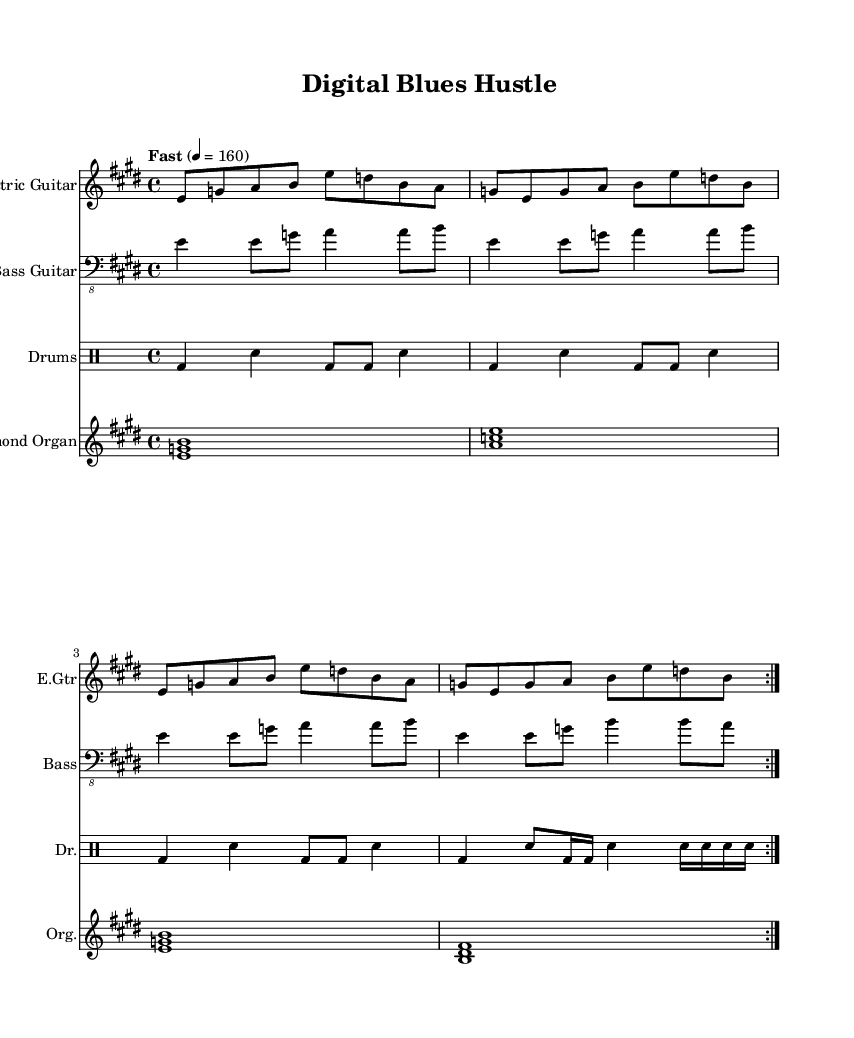What is the key signature of this music? The key signature is E major, which has four sharps: F#, C#, G#, and D#. This can be determined by looking at the key indicated at the beginning of the score.
Answer: E major What is the time signature of this music? The time signature is 4/4, which is indicated at the beginning of the score. This means there are four beats in each measure, and the quarter note gets one beat.
Answer: 4/4 What is the tempo marking for this piece? The tempo marking is "Fast" and indicates a speed of 160 beats per minute. This is found at the beginning of the score, where tempo indications are typically placed.
Answer: Fast How many times is the main electric guitar part repeated? The main electric guitar part is repeated 2 times, as indicated by the volta marking in the score which shows repetitions within the music.
Answer: 2 What is the instrumentation featured in this piece? The instrumentation includes Electric Guitar, Bass Guitar, Drums, and Hammond Organ, as listed under each staff in the score. This captures the essence of electric blues with a mix of traditional and modern instruments.
Answer: Electric Guitar, Bass Guitar, Drums, Hammond Organ Which instrument plays the bass line? The Bass Guitar plays the bass line, as indicated in the score where it is labeled as the staff for the bass instrument. This part typically provides harmonic support and rhythm in electric blues.
Answer: Bass Guitar What type of musical form does this piece resemble? This piece resembles a repeated verse-chorus structure common in blues music, where the electric guitar part and the bass line showcase a repetitive and catchy pattern characteristic of the genre.
Answer: Verse-chorus 